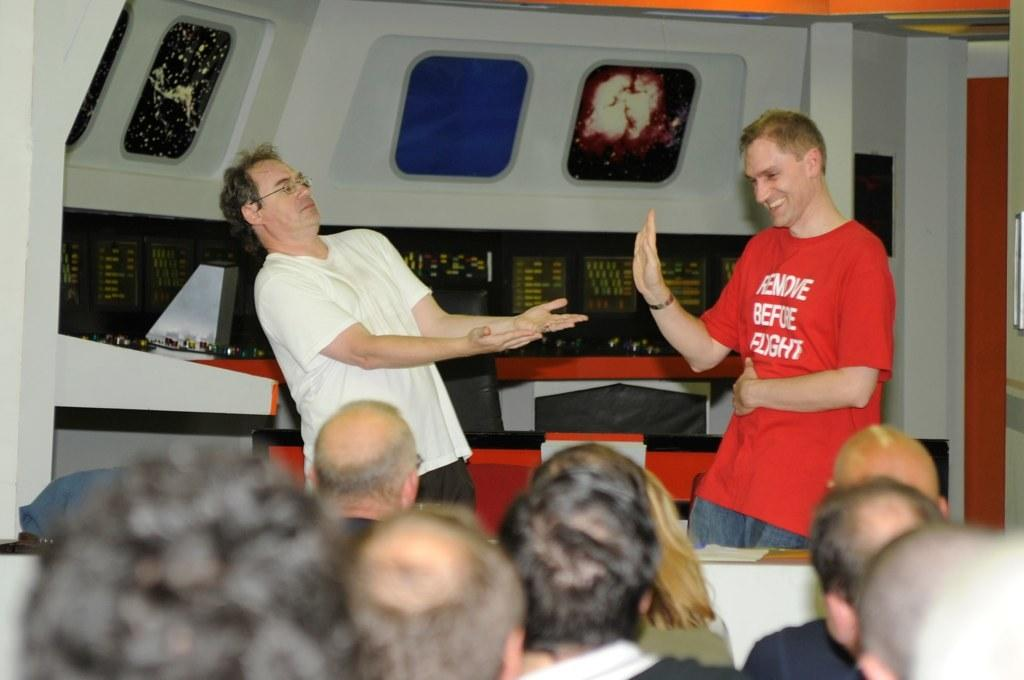Who or what can be seen in the image? There are people in the image. What are some of the people wearing? Some of the people are wearing glasses. What can be seen in the background of the image? There are objects and text visible on boards in the background. What structures are present in the image? There are stands present in the image. How many sheep can be seen grazing in the field in the image? There is no field or sheep present in the image. What type of bee is buzzing around the people in the image? There are no bees present in the image. 